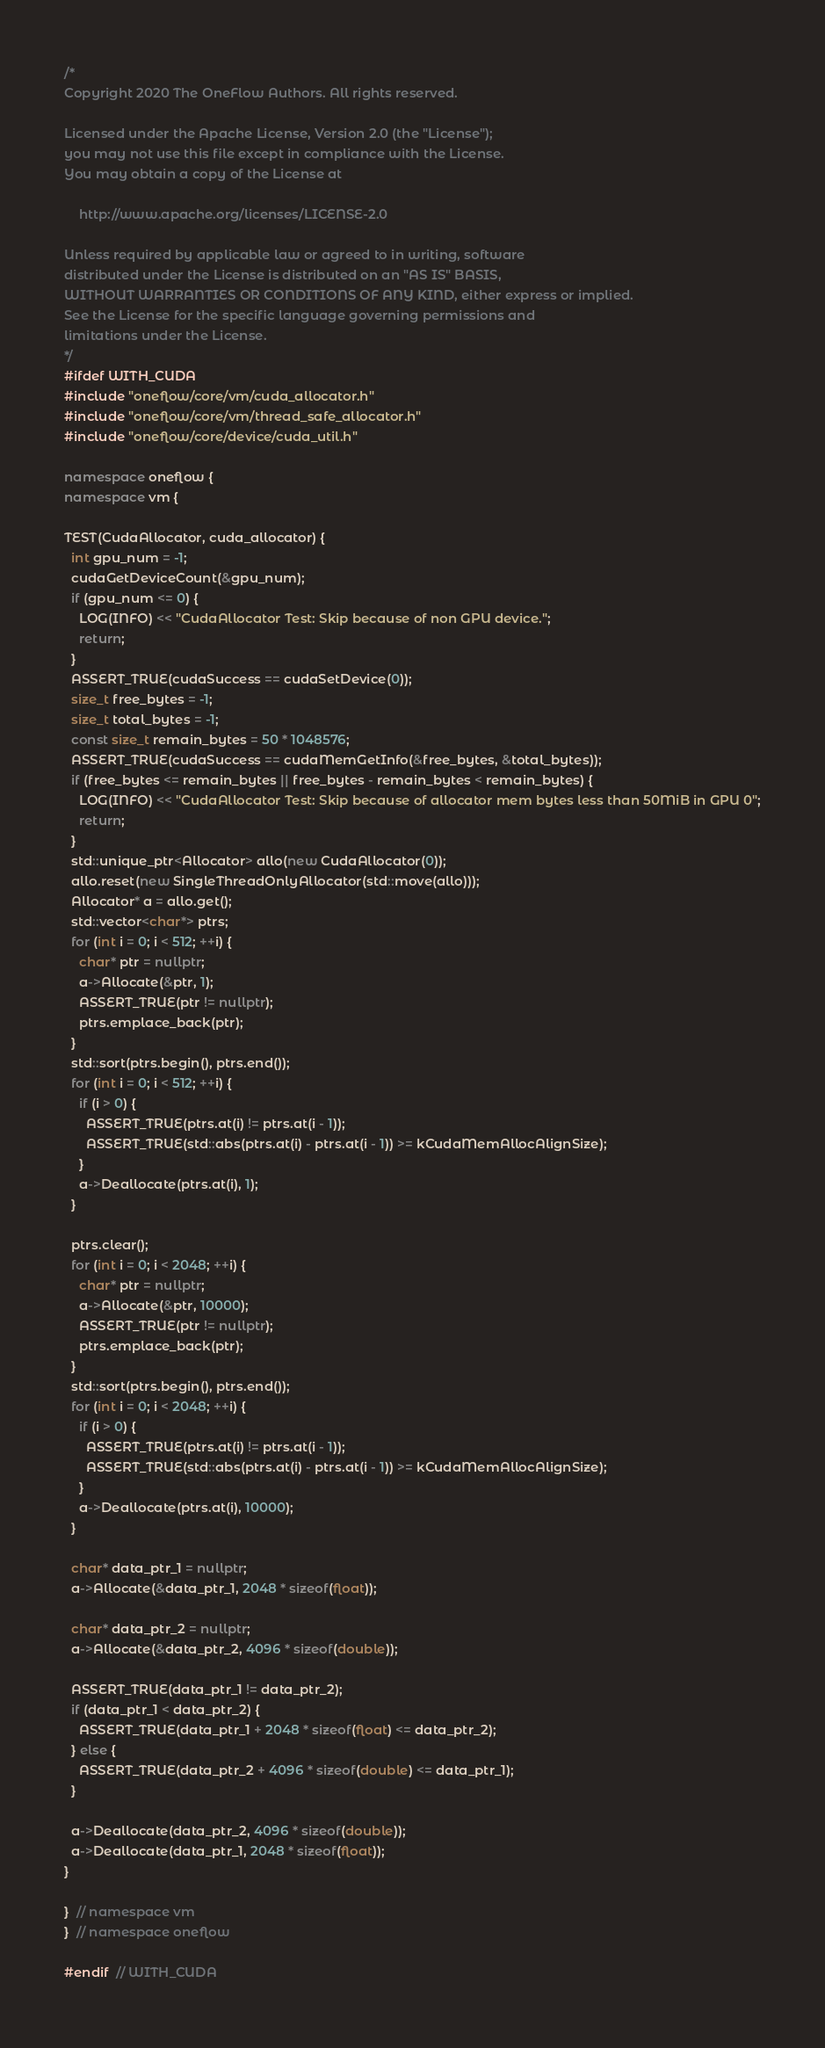Convert code to text. <code><loc_0><loc_0><loc_500><loc_500><_C++_>/*
Copyright 2020 The OneFlow Authors. All rights reserved.

Licensed under the Apache License, Version 2.0 (the "License");
you may not use this file except in compliance with the License.
You may obtain a copy of the License at

    http://www.apache.org/licenses/LICENSE-2.0

Unless required by applicable law or agreed to in writing, software
distributed under the License is distributed on an "AS IS" BASIS,
WITHOUT WARRANTIES OR CONDITIONS OF ANY KIND, either express or implied.
See the License for the specific language governing permissions and
limitations under the License.
*/
#ifdef WITH_CUDA
#include "oneflow/core/vm/cuda_allocator.h"
#include "oneflow/core/vm/thread_safe_allocator.h"
#include "oneflow/core/device/cuda_util.h"

namespace oneflow {
namespace vm {

TEST(CudaAllocator, cuda_allocator) {
  int gpu_num = -1;
  cudaGetDeviceCount(&gpu_num);
  if (gpu_num <= 0) {
    LOG(INFO) << "CudaAllocator Test: Skip because of non GPU device.";
    return;
  }
  ASSERT_TRUE(cudaSuccess == cudaSetDevice(0));
  size_t free_bytes = -1;
  size_t total_bytes = -1;
  const size_t remain_bytes = 50 * 1048576;
  ASSERT_TRUE(cudaSuccess == cudaMemGetInfo(&free_bytes, &total_bytes));
  if (free_bytes <= remain_bytes || free_bytes - remain_bytes < remain_bytes) {
    LOG(INFO) << "CudaAllocator Test: Skip because of allocator mem bytes less than 50MiB in GPU 0";
    return;
  }
  std::unique_ptr<Allocator> allo(new CudaAllocator(0));
  allo.reset(new SingleThreadOnlyAllocator(std::move(allo)));
  Allocator* a = allo.get();
  std::vector<char*> ptrs;
  for (int i = 0; i < 512; ++i) {
    char* ptr = nullptr;
    a->Allocate(&ptr, 1);
    ASSERT_TRUE(ptr != nullptr);
    ptrs.emplace_back(ptr);
  }
  std::sort(ptrs.begin(), ptrs.end());
  for (int i = 0; i < 512; ++i) {
    if (i > 0) {
      ASSERT_TRUE(ptrs.at(i) != ptrs.at(i - 1));
      ASSERT_TRUE(std::abs(ptrs.at(i) - ptrs.at(i - 1)) >= kCudaMemAllocAlignSize);
    }
    a->Deallocate(ptrs.at(i), 1);
  }

  ptrs.clear();
  for (int i = 0; i < 2048; ++i) {
    char* ptr = nullptr;
    a->Allocate(&ptr, 10000);
    ASSERT_TRUE(ptr != nullptr);
    ptrs.emplace_back(ptr);
  }
  std::sort(ptrs.begin(), ptrs.end());
  for (int i = 0; i < 2048; ++i) {
    if (i > 0) {
      ASSERT_TRUE(ptrs.at(i) != ptrs.at(i - 1));
      ASSERT_TRUE(std::abs(ptrs.at(i) - ptrs.at(i - 1)) >= kCudaMemAllocAlignSize);
    }
    a->Deallocate(ptrs.at(i), 10000);
  }

  char* data_ptr_1 = nullptr;
  a->Allocate(&data_ptr_1, 2048 * sizeof(float));

  char* data_ptr_2 = nullptr;
  a->Allocate(&data_ptr_2, 4096 * sizeof(double));

  ASSERT_TRUE(data_ptr_1 != data_ptr_2);
  if (data_ptr_1 < data_ptr_2) {
    ASSERT_TRUE(data_ptr_1 + 2048 * sizeof(float) <= data_ptr_2);
  } else {
    ASSERT_TRUE(data_ptr_2 + 4096 * sizeof(double) <= data_ptr_1);
  }

  a->Deallocate(data_ptr_2, 4096 * sizeof(double));
  a->Deallocate(data_ptr_1, 2048 * sizeof(float));
}

}  // namespace vm
}  // namespace oneflow

#endif  // WITH_CUDA
</code> 